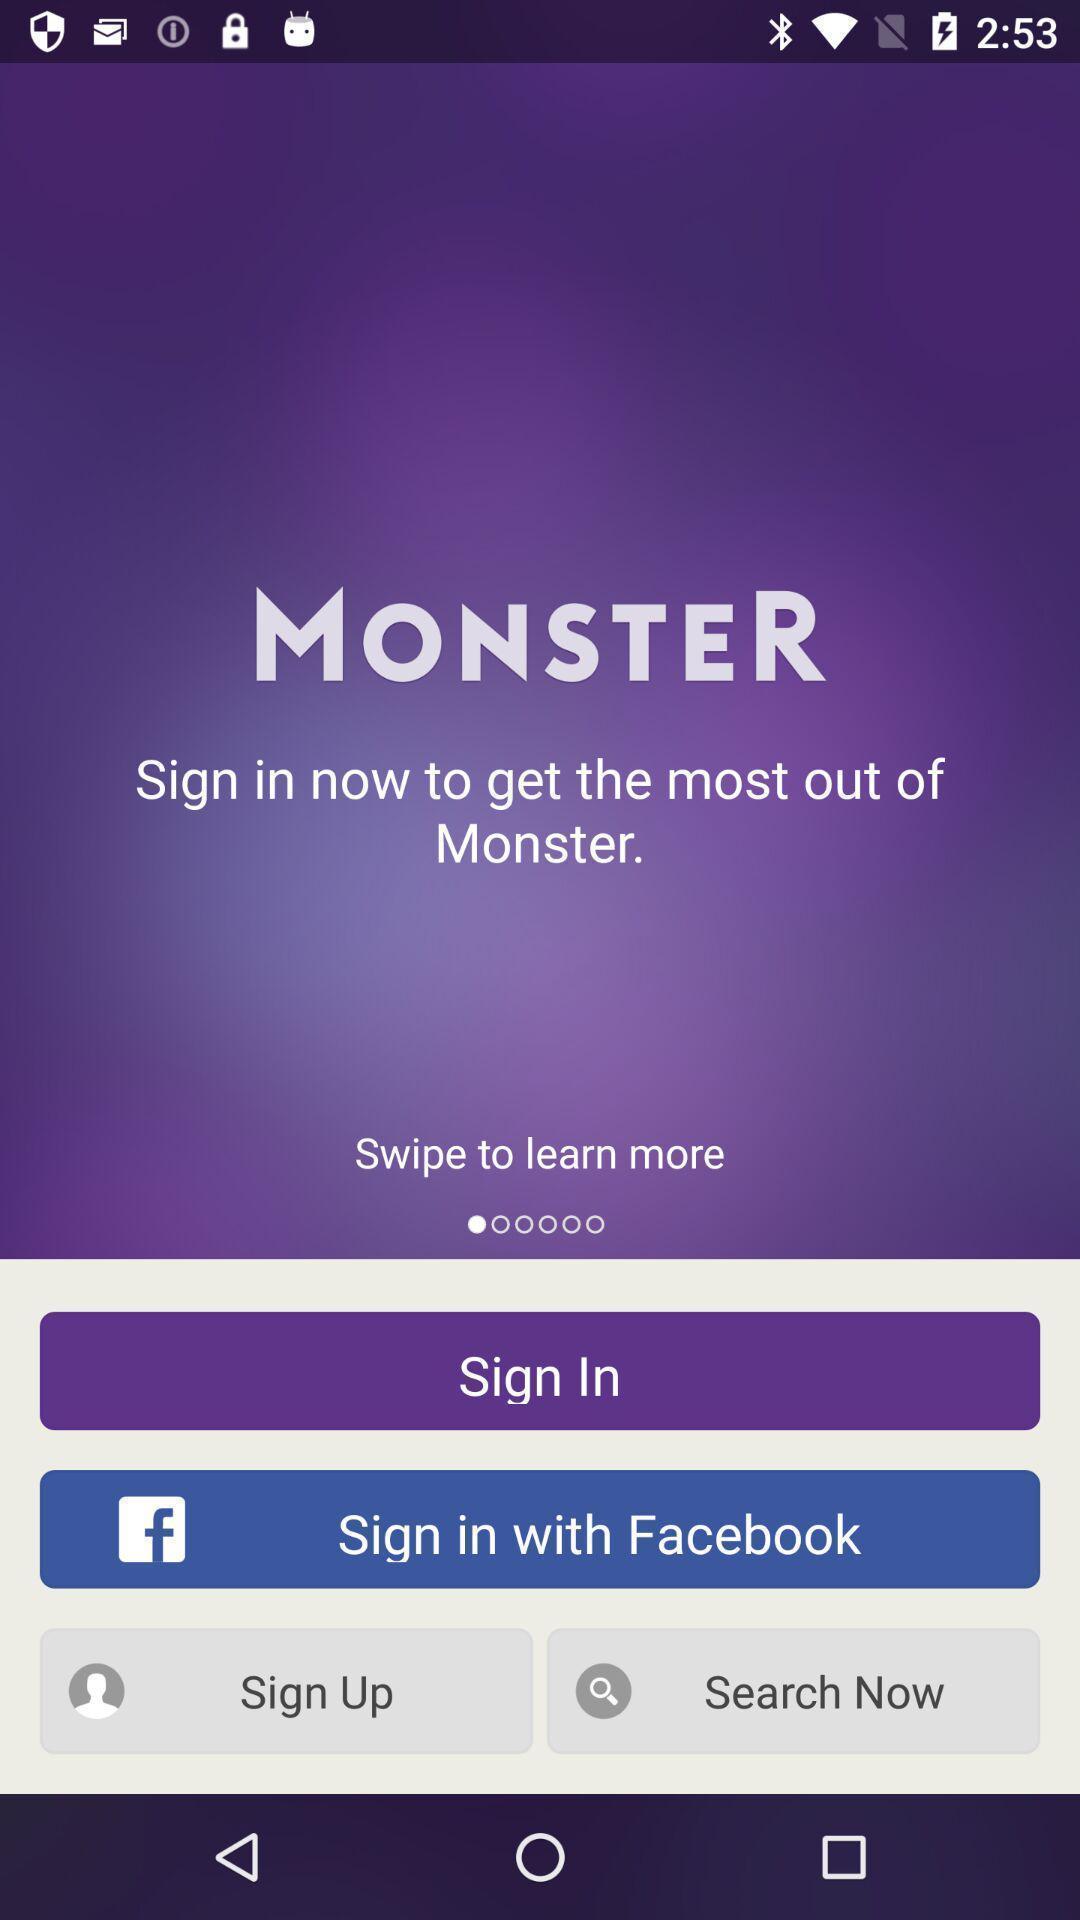Provide a textual representation of this image. Welcome page displaying options to sign in and sign up. 